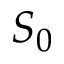Convert formula to latex. <formula><loc_0><loc_0><loc_500><loc_500>S _ { 0 }</formula> 